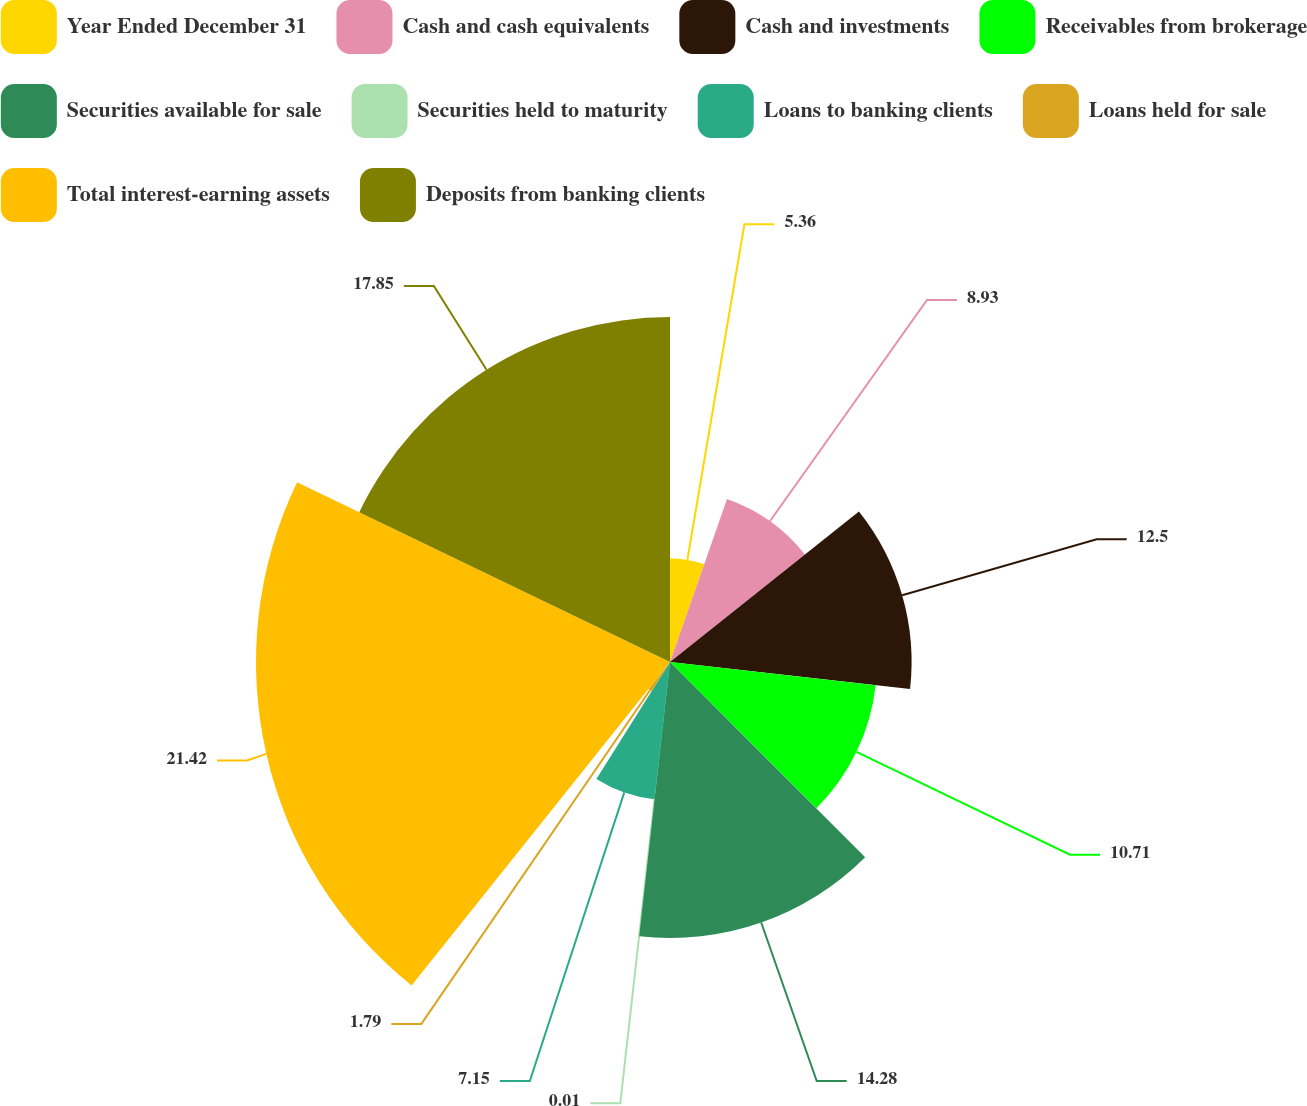<chart> <loc_0><loc_0><loc_500><loc_500><pie_chart><fcel>Year Ended December 31<fcel>Cash and cash equivalents<fcel>Cash and investments<fcel>Receivables from brokerage<fcel>Securities available for sale<fcel>Securities held to maturity<fcel>Loans to banking clients<fcel>Loans held for sale<fcel>Total interest-earning assets<fcel>Deposits from banking clients<nl><fcel>5.36%<fcel>8.93%<fcel>12.5%<fcel>10.71%<fcel>14.28%<fcel>0.01%<fcel>7.15%<fcel>1.79%<fcel>21.42%<fcel>17.85%<nl></chart> 